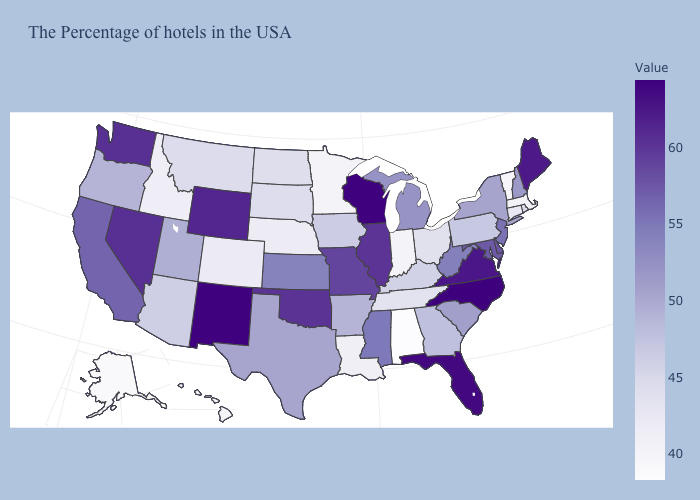Does Pennsylvania have a lower value than New York?
Short answer required. Yes. Does Nevada have a higher value than Tennessee?
Short answer required. Yes. Does Alabama have the lowest value in the USA?
Answer briefly. Yes. Among the states that border New York , which have the highest value?
Short answer required. New Jersey. Does Idaho have a higher value than Pennsylvania?
Quick response, please. No. 